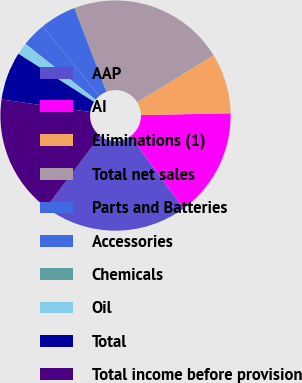Convert chart to OTSL. <chart><loc_0><loc_0><loc_500><loc_500><pie_chart><fcel>AAP<fcel>AI<fcel>Eliminations (1)<fcel>Total net sales<fcel>Parts and Batteries<fcel>Accessories<fcel>Chemicals<fcel>Oil<fcel>Total<fcel>Total income before provision<nl><fcel>20.34%<fcel>15.25%<fcel>8.47%<fcel>22.03%<fcel>5.08%<fcel>3.39%<fcel>0.0%<fcel>1.69%<fcel>6.78%<fcel>16.95%<nl></chart> 